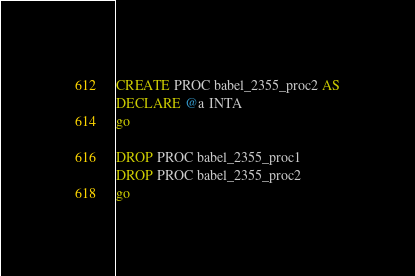Convert code to text. <code><loc_0><loc_0><loc_500><loc_500><_SQL_>
CREATE PROC babel_2355_proc2 AS
DECLARE @a INTA
go

DROP PROC babel_2355_proc1
DROP PROC babel_2355_proc2
go
</code> 